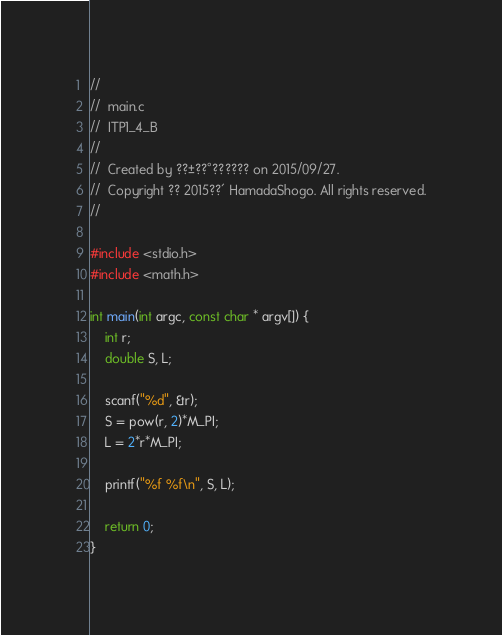Convert code to text. <code><loc_0><loc_0><loc_500><loc_500><_C_>//
//  main.c
//  ITP1_4_B
//
//  Created by ??±??°?????? on 2015/09/27.
//  Copyright ?? 2015??´ HamadaShogo. All rights reserved.
//

#include <stdio.h>
#include <math.h>

int main(int argc, const char * argv[]) {
    int r;
    double S, L;
    
    scanf("%d", &r);
    S = pow(r, 2)*M_PI;
    L = 2*r*M_PI;
    
    printf("%f %f\n", S, L);
    
    return 0;
}</code> 